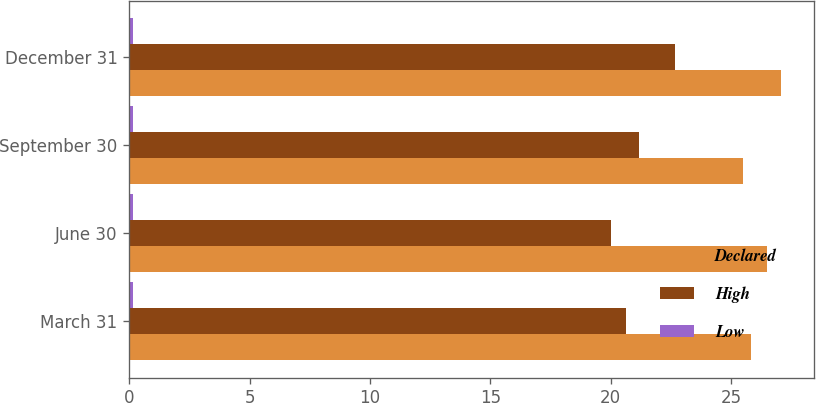<chart> <loc_0><loc_0><loc_500><loc_500><stacked_bar_chart><ecel><fcel>March 31<fcel>June 30<fcel>September 30<fcel>December 31<nl><fcel>Declared<fcel>25.83<fcel>26.48<fcel>25.5<fcel>27.08<nl><fcel>High<fcel>20.63<fcel>20<fcel>21.19<fcel>22.68<nl><fcel>Low<fcel>0.15<fcel>0.15<fcel>0.15<fcel>0.15<nl></chart> 